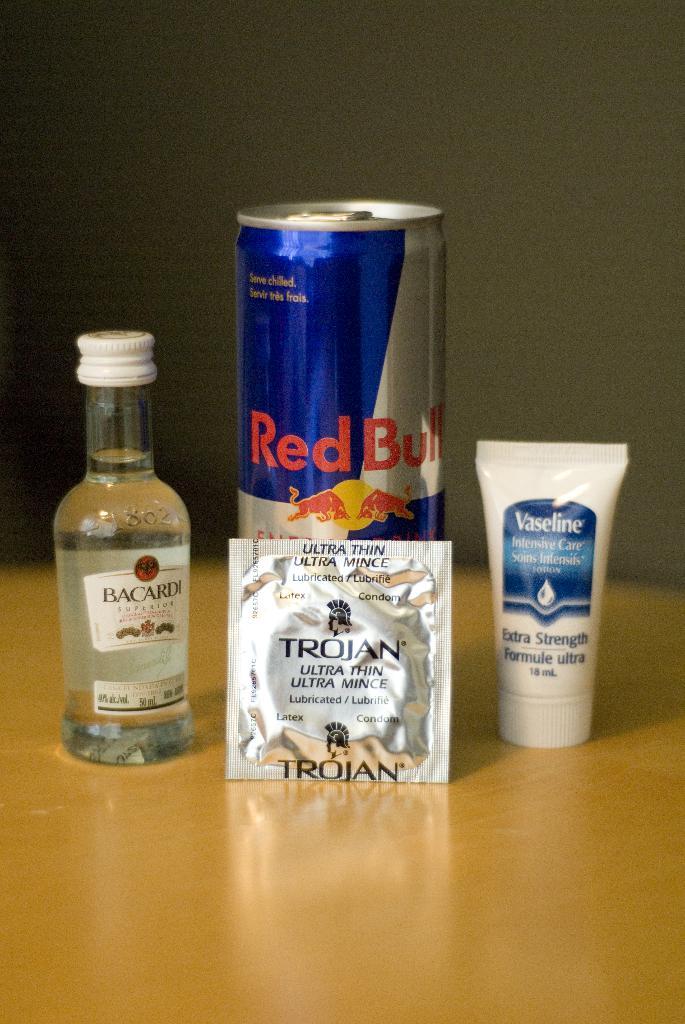What type of beverage is this?
Provide a succinct answer. Red bull. 